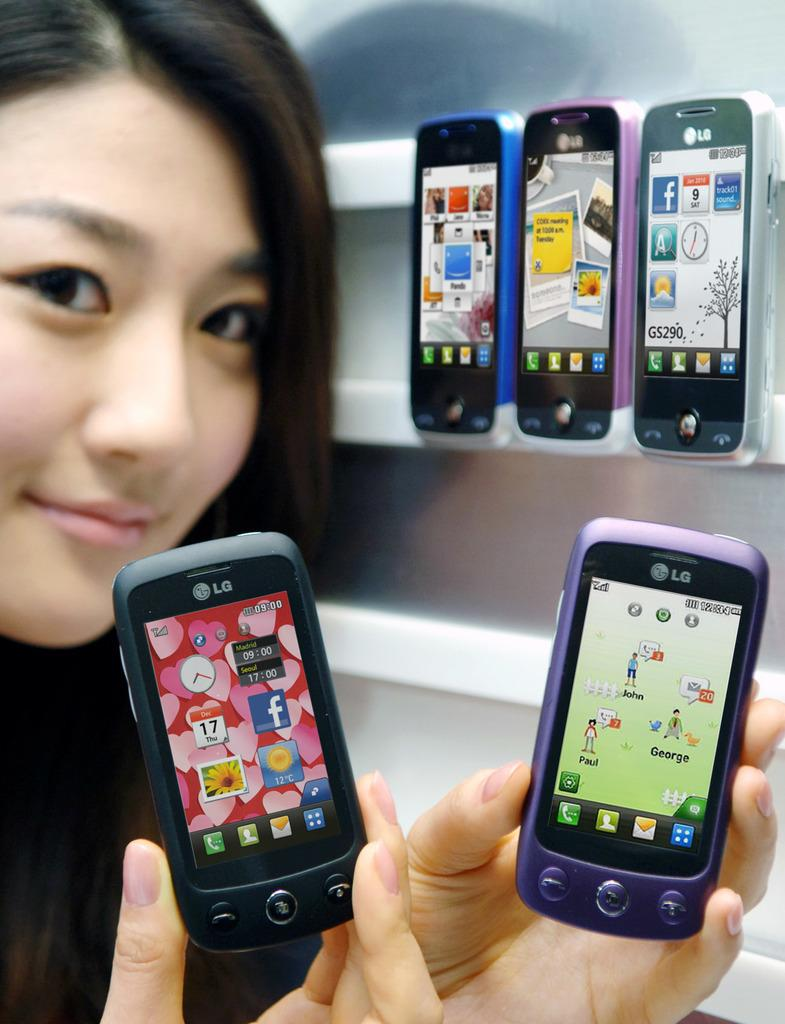<image>
Provide a brief description of the given image. A woman holding LG phones that are purple and black 